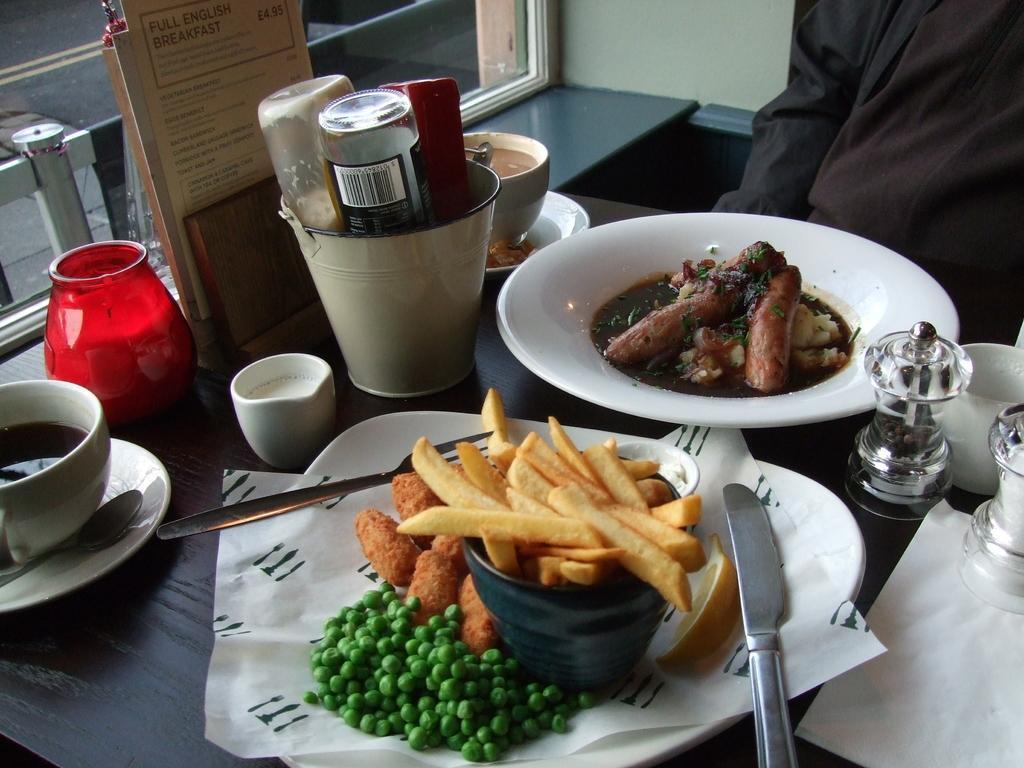Please provide a concise description of this image. In this picture I can see food items on the plates, there is a spoon, fork and a knife, there are salt and pepper jars, there are cups with liquids in it, there are saucers and some other objects on the table, and in the background there is a wall and a window. 